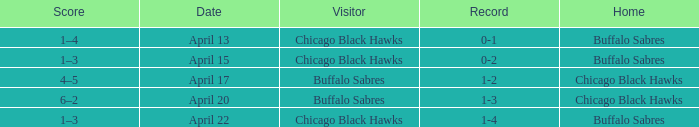Which Date has a Record of 1-4? April 22. 